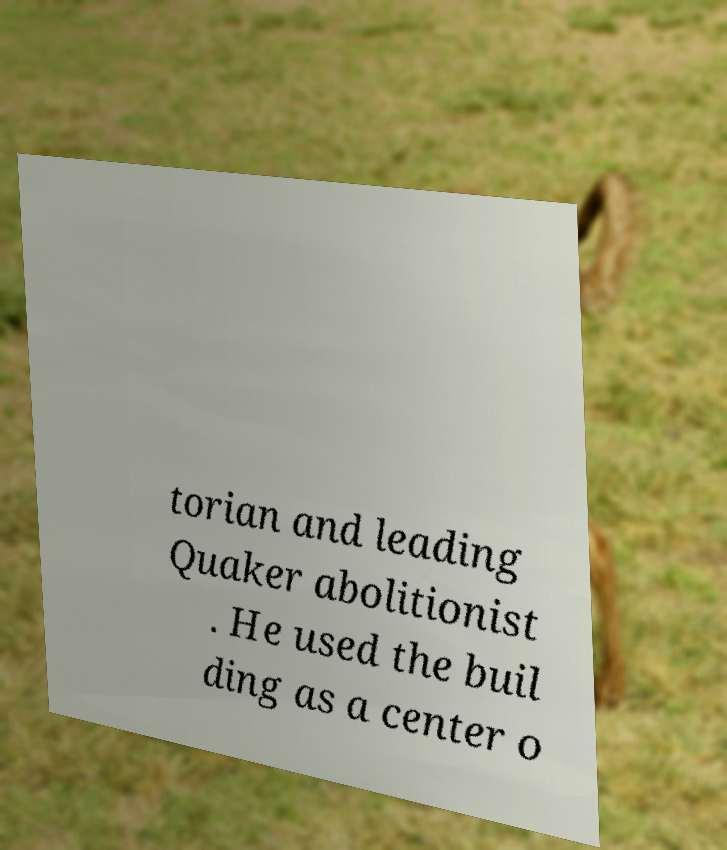Could you assist in decoding the text presented in this image and type it out clearly? torian and leading Quaker abolitionist . He used the buil ding as a center o 